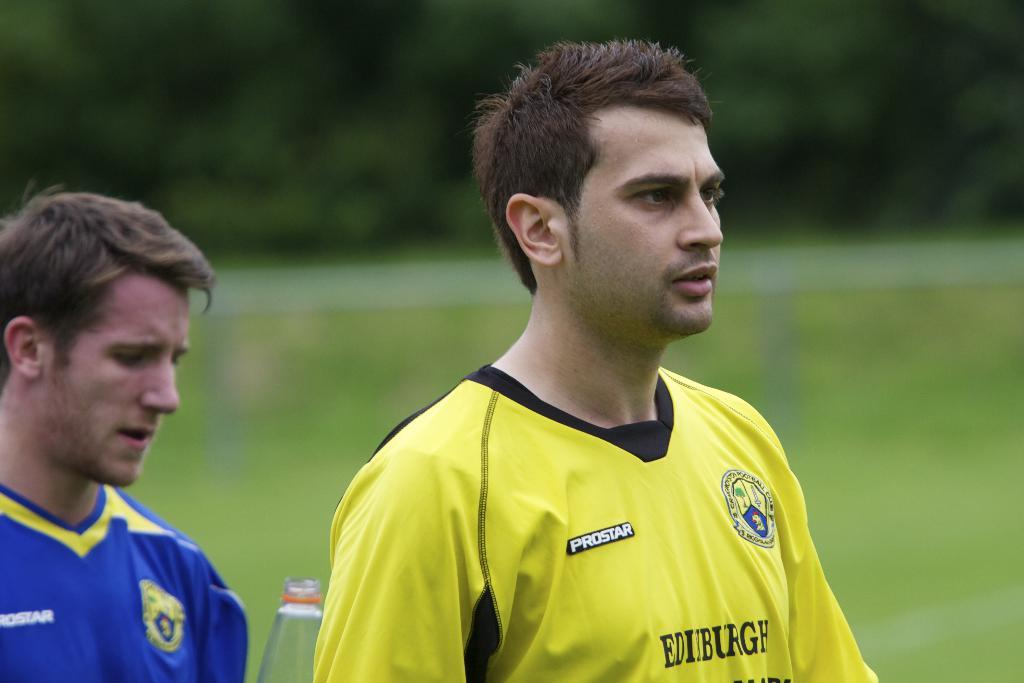<image>
Summarize the visual content of the image. two soccer players from opposing teams in the prostar league 